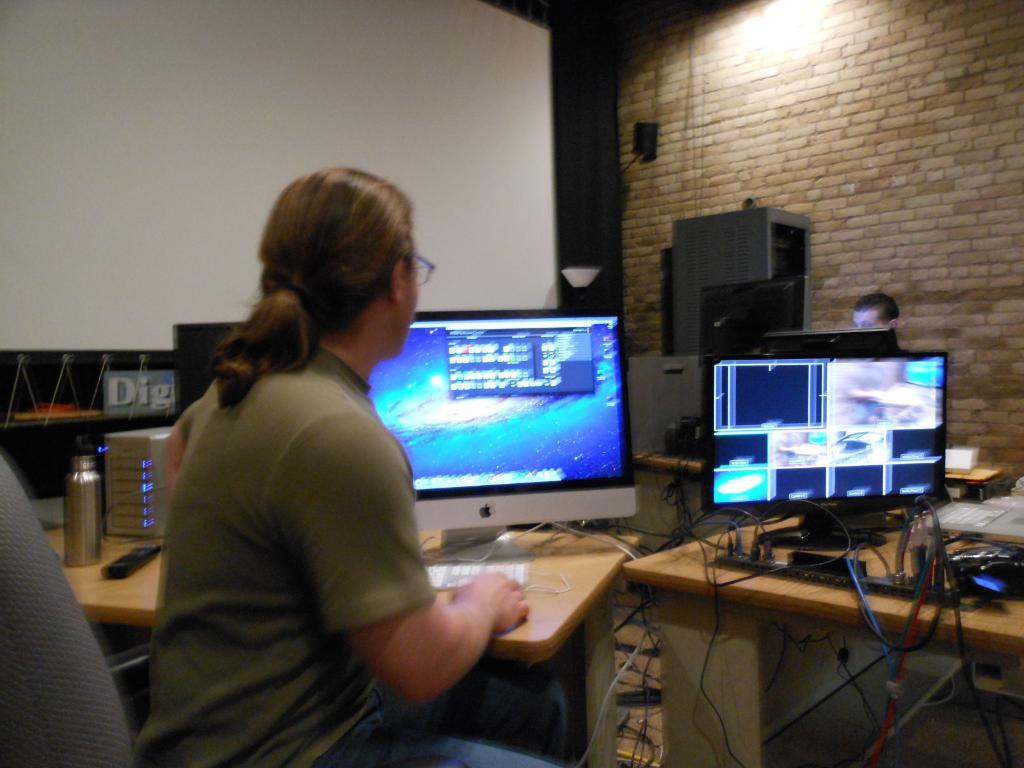Who is present in the image? There is a woman in the image. What is the woman doing in the image? The woman is sitting in front of a monitor. Where is the monitor located? The monitor is on a table. What can be seen near the woman in the image? There is a water bottle in the image. What else can be seen in the image? There are cables visible in the image. What type of substance is being kicked around by the woman in the image? There is no indication in the image that the woman is kicking any substance; she is sitting in front of a monitor. 